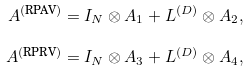Convert formula to latex. <formula><loc_0><loc_0><loc_500><loc_500>A ^ { ( \text {RPAV} ) } = I _ { N } \otimes A _ { 1 } + L ^ { ( D ) } \otimes A _ { 2 } , \\ A ^ { ( \text {RPRV} ) } = I _ { N } \otimes A _ { 3 } + L ^ { ( D ) } \otimes A _ { 4 } ,</formula> 